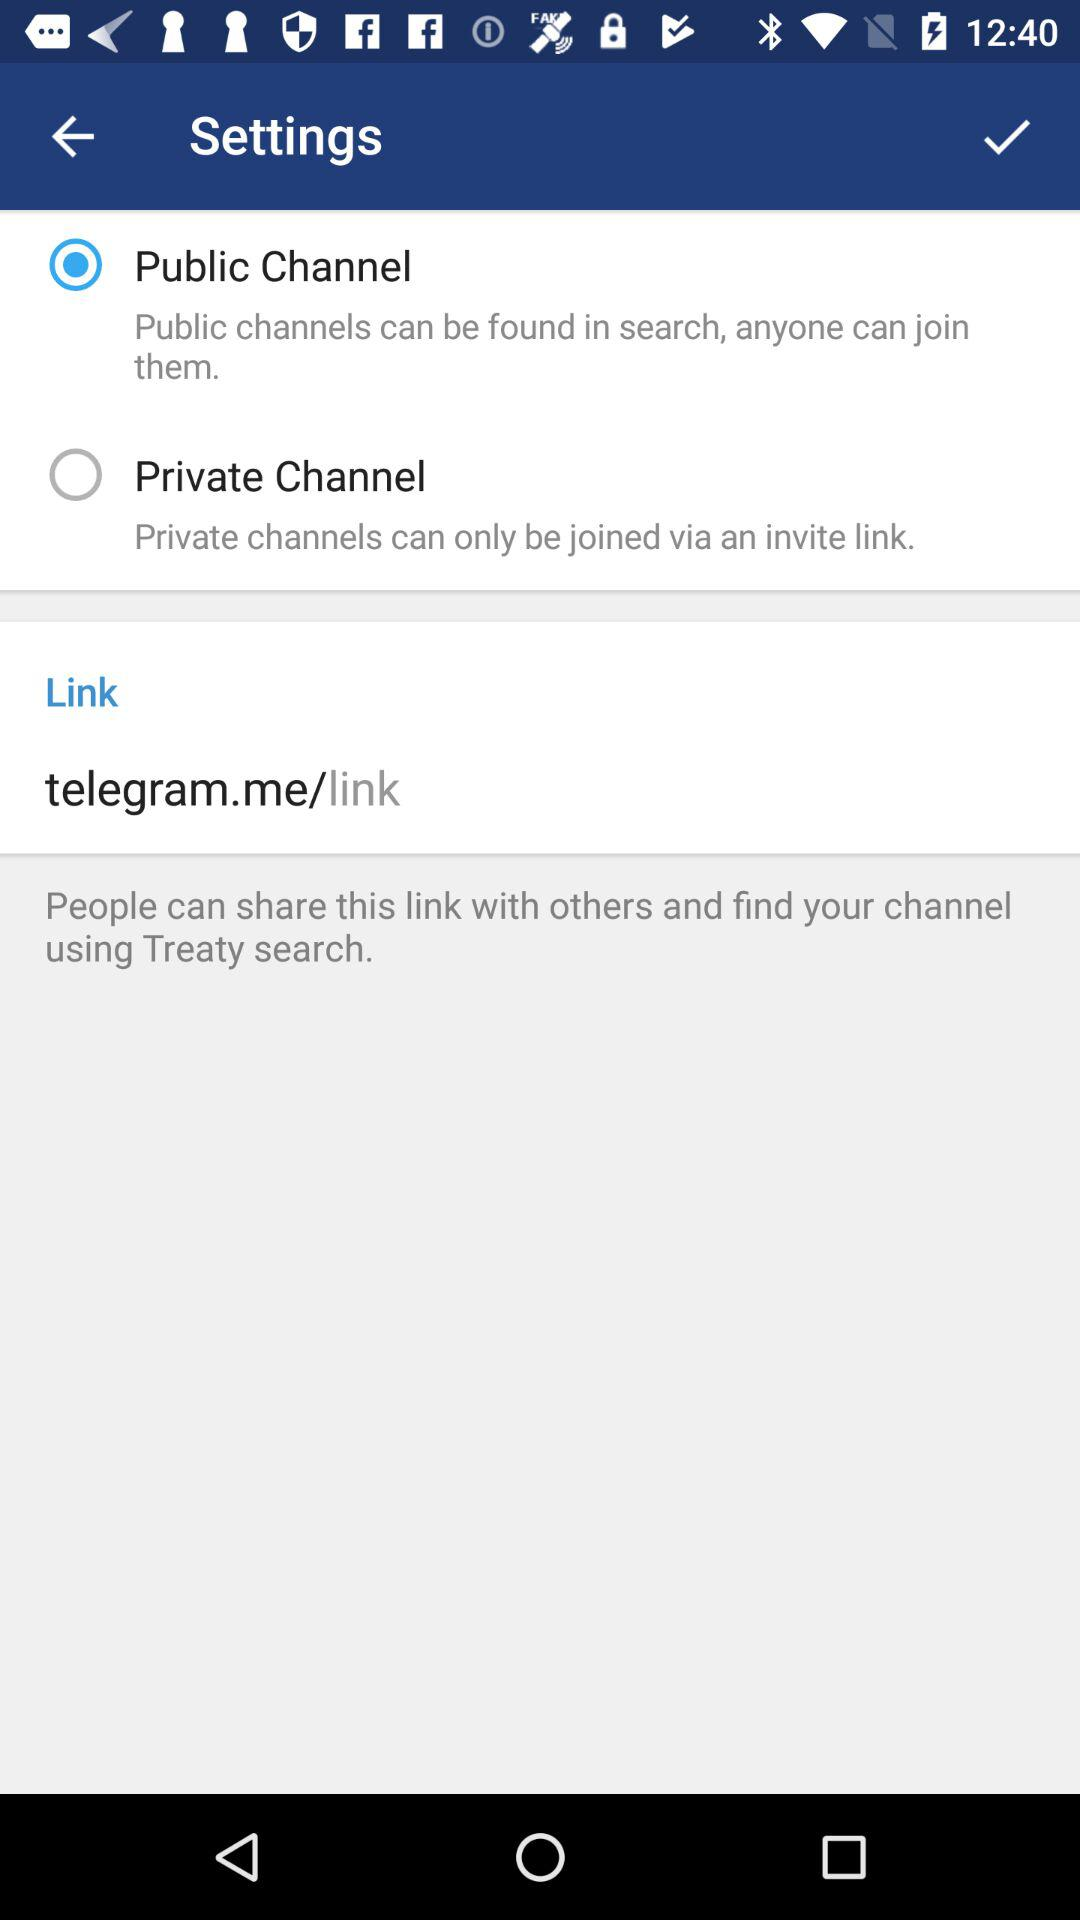What is the status of the "Settings"? The status is "Public Channel". 